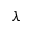<formula> <loc_0><loc_0><loc_500><loc_500>\lambda</formula> 